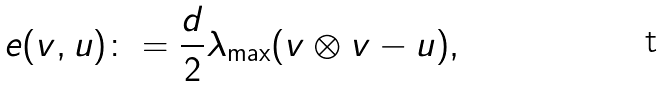Convert formula to latex. <formula><loc_0><loc_0><loc_500><loc_500>e ( v , u ) \colon = \frac { d } { 2 } \lambda _ { \max } ( v \otimes v - u ) ,</formula> 